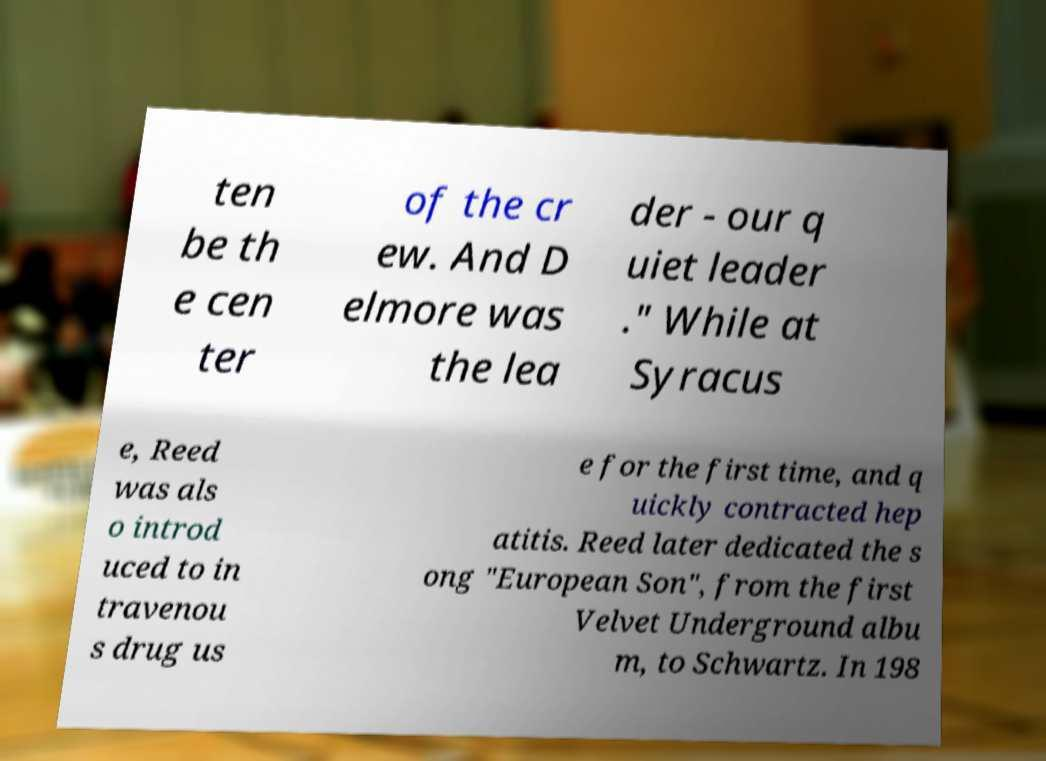Please identify and transcribe the text found in this image. ten be th e cen ter of the cr ew. And D elmore was the lea der - our q uiet leader ." While at Syracus e, Reed was als o introd uced to in travenou s drug us e for the first time, and q uickly contracted hep atitis. Reed later dedicated the s ong "European Son", from the first Velvet Underground albu m, to Schwartz. In 198 